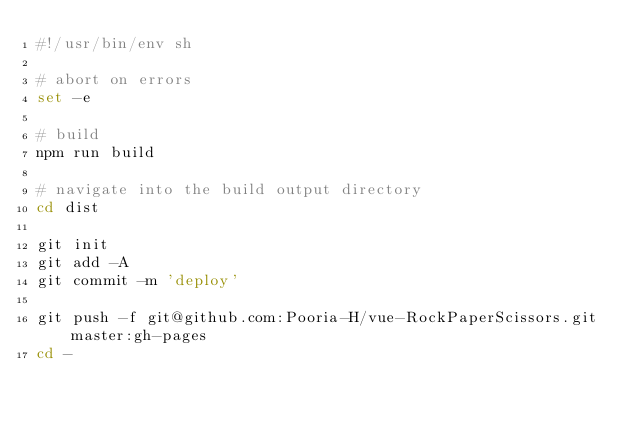<code> <loc_0><loc_0><loc_500><loc_500><_Bash_>#!/usr/bin/env sh

# abort on errors
set -e

# build
npm run build

# navigate into the build output directory
cd dist

git init
git add -A
git commit -m 'deploy'

git push -f git@github.com:Pooria-H/vue-RockPaperScissors.git master:gh-pages
cd -</code> 